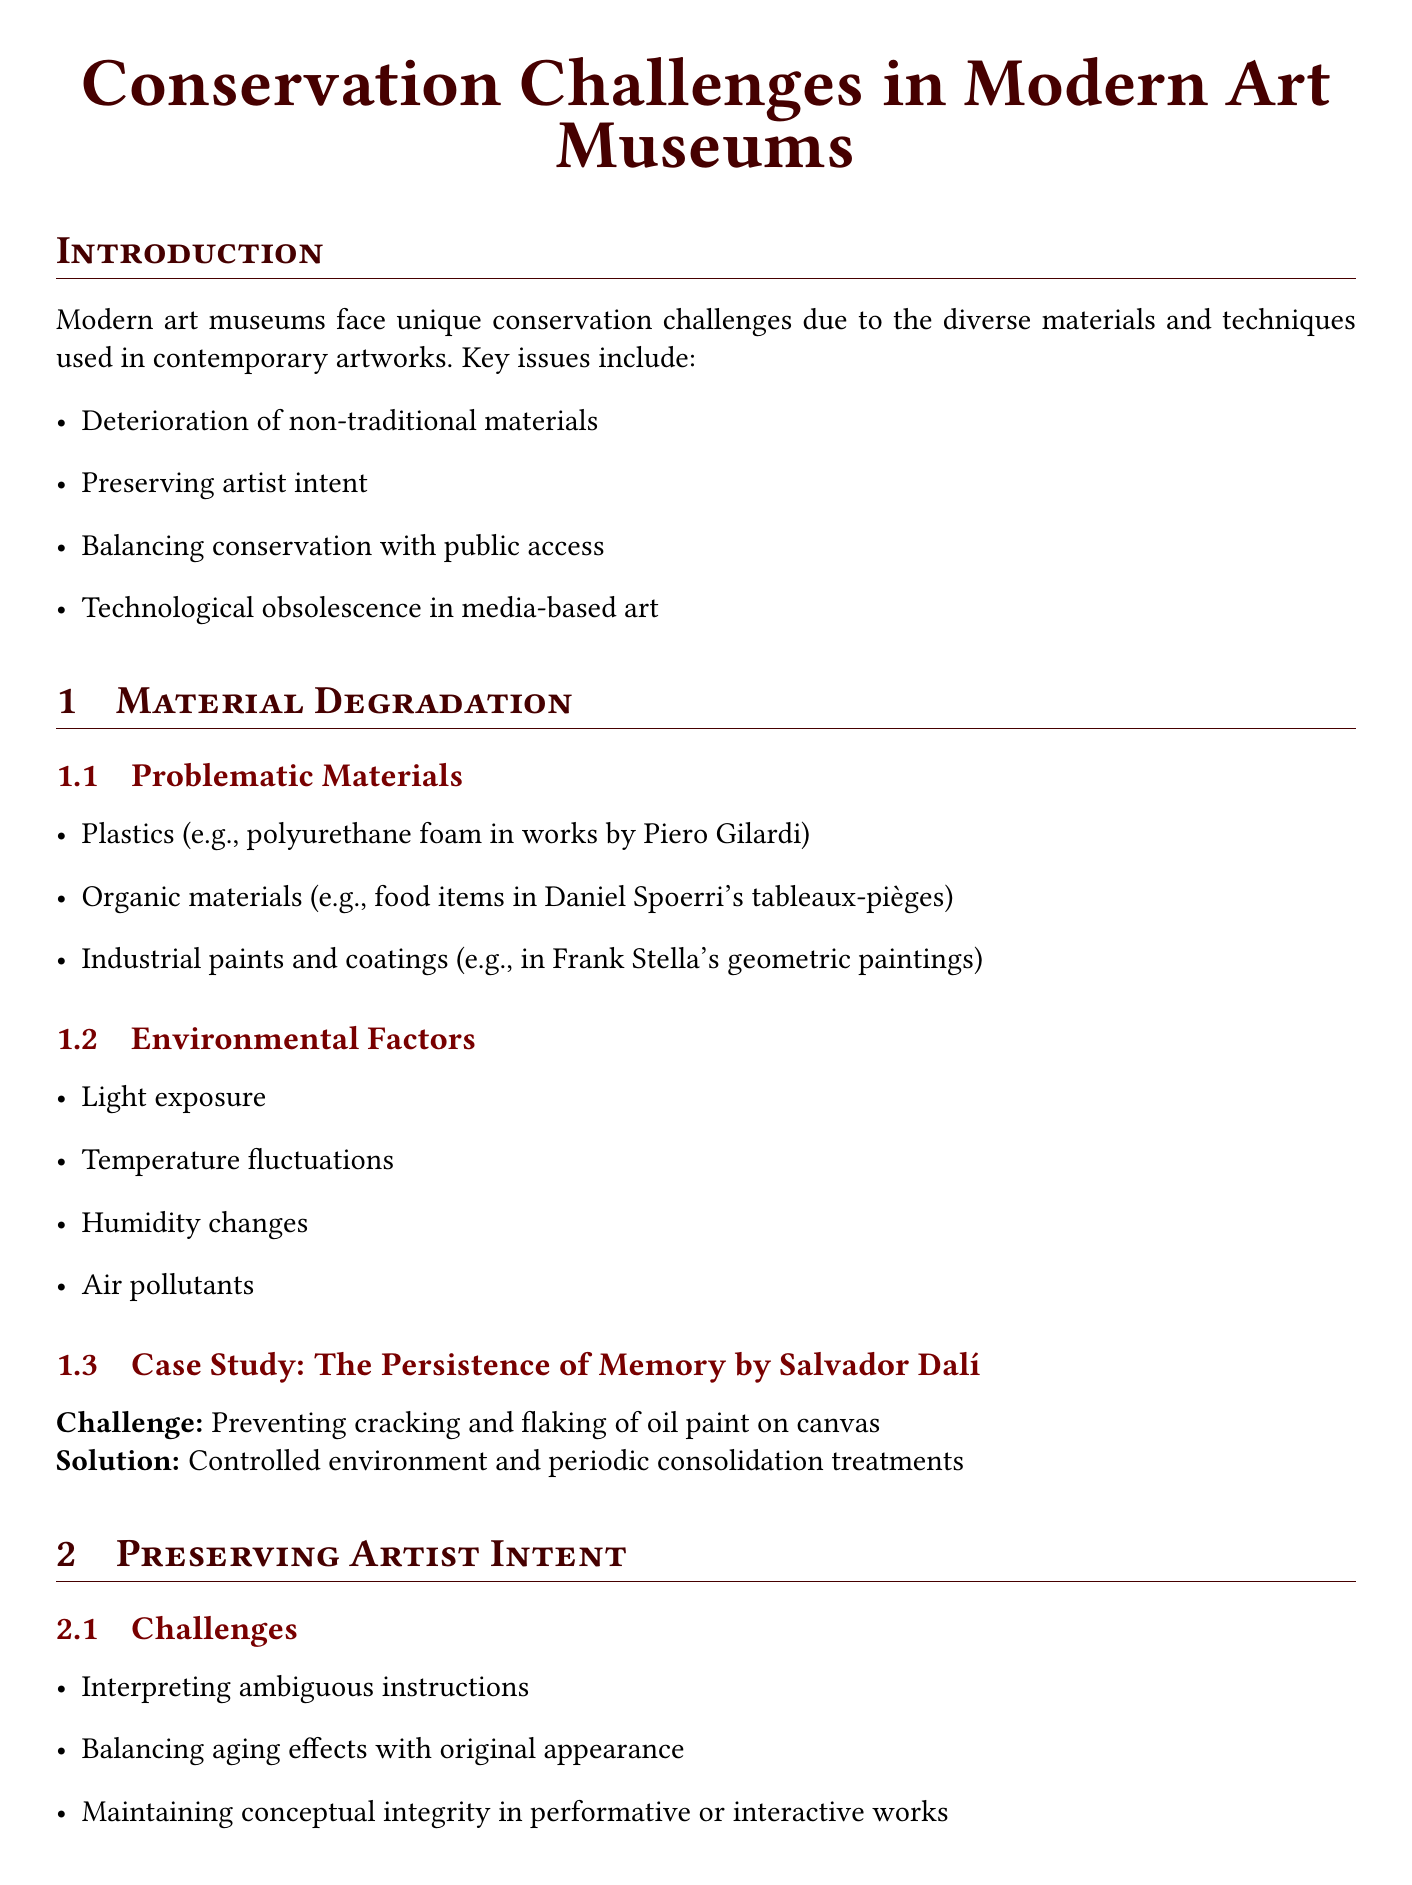what is the first key issue modern art museums face? The first key issue mentioned in the introduction is the deterioration of non-traditional materials.
Answer: deterioration of non-traditional materials what is one example of a problematic material in contemporary art? The document lists several problematic materials, one of which is plastics, such as polyurethane foam in works by Piero Gilardi.
Answer: plastics which artwork is used as a case study for material degradation? The case study focuses on "The Persistence of Memory" by Salvador Dalí.
Answer: The Persistence of Memory what method is used for creating digital archives of sculptural works? The document states that 3D scanning and modeling is the method used for this purpose.
Answer: 3D scanning and modeling what is one preservation strategy against technological obsolescence? One strategy mentioned is the migration to new formats.
Answer: migration to new formats name one ethical issue related to modern art conservation discussed in the report. One ethical issue is the authenticity vs. longevity debate.
Answer: authenticity vs. longevity what example of an artwork faces challenges related to artist intent? The example provided is Damien Hirst's "The Physical Impossibility of Death in the Mind of Someone Living."
Answer: The Physical Impossibility of Death in the Mind of Someone Living which innovative preservation technique involves non-invasive analysis of materials? The document refers to non-invasive spectroscopic techniques as the innovative preservation technique.
Answer: non-invasive spectroscopic techniques what is a future challenge mentioned in the report affecting art conservation? The report mentions the conservation of digital and internet-based art as a future challenge.
Answer: conservation of digital and internet-based art 